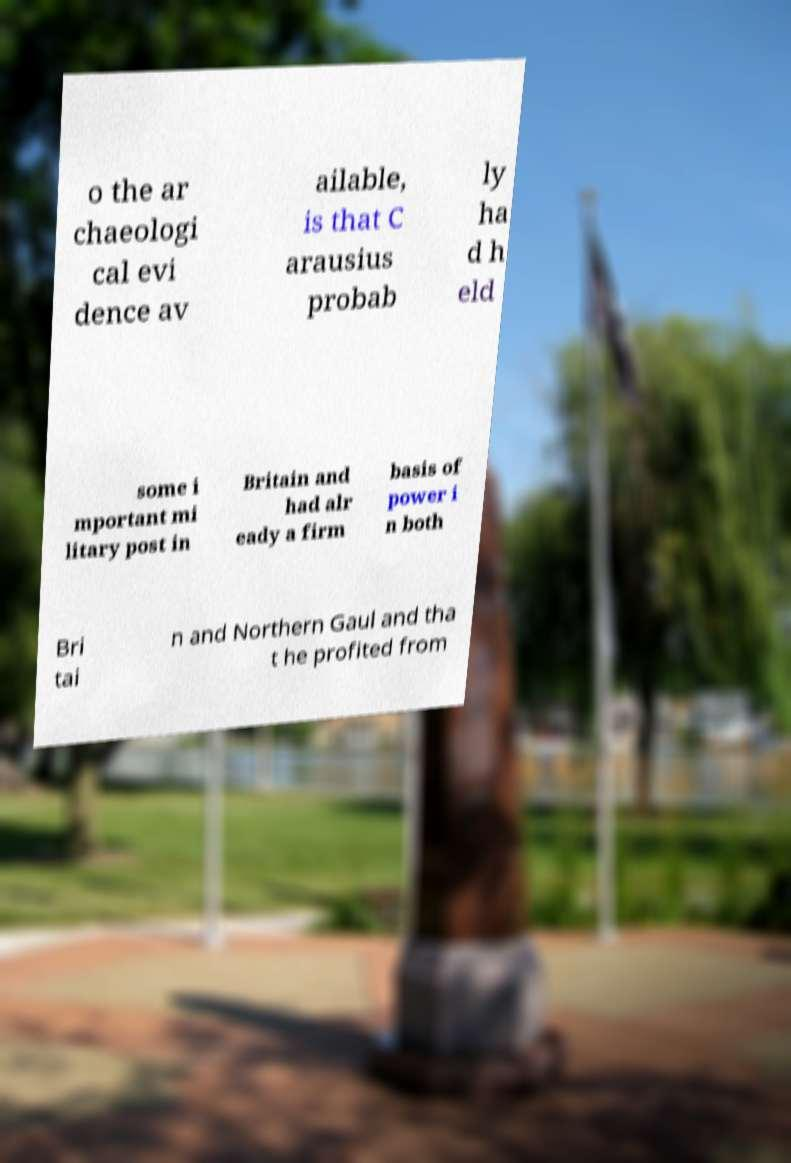Please read and relay the text visible in this image. What does it say? o the ar chaeologi cal evi dence av ailable, is that C arausius probab ly ha d h eld some i mportant mi litary post in Britain and had alr eady a firm basis of power i n both Bri tai n and Northern Gaul and tha t he profited from 